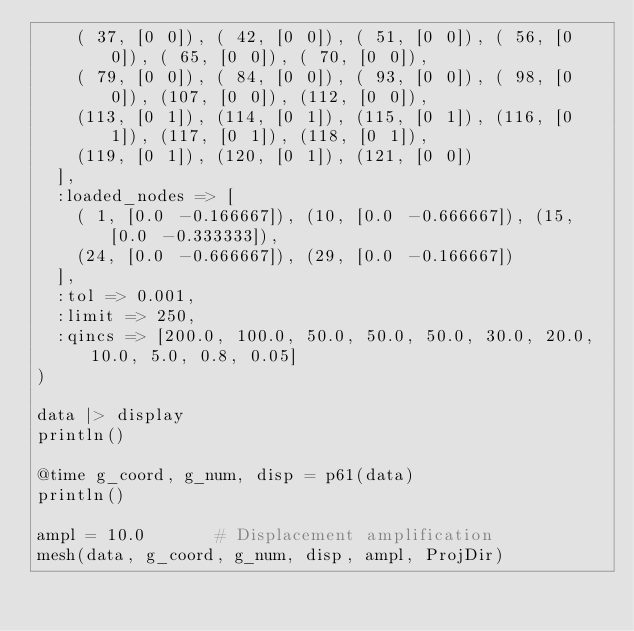<code> <loc_0><loc_0><loc_500><loc_500><_Julia_>    ( 37, [0 0]), ( 42, [0 0]), ( 51, [0 0]), ( 56, [0 0]), ( 65, [0 0]), ( 70, [0 0]),
    ( 79, [0 0]), ( 84, [0 0]), ( 93, [0 0]), ( 98, [0 0]), (107, [0 0]), (112, [0 0]),
    (113, [0 1]), (114, [0 1]), (115, [0 1]), (116, [0 1]), (117, [0 1]), (118, [0 1]),
    (119, [0 1]), (120, [0 1]), (121, [0 0])
  ],
  :loaded_nodes => [
    ( 1, [0.0 -0.166667]), (10, [0.0 -0.666667]), (15, [0.0 -0.333333]),
    (24, [0.0 -0.666667]), (29, [0.0 -0.166667])
  ],
  :tol => 0.001,
  :limit => 250,
  :qincs => [200.0, 100.0, 50.0, 50.0, 50.0, 30.0, 20.0, 10.0, 5.0, 0.8, 0.05]
)

data |> display
println()

@time g_coord, g_num, disp = p61(data)
println()

ampl = 10.0       # Displacement amplification
mesh(data, g_coord, g_num, disp, ampl, ProjDir)</code> 